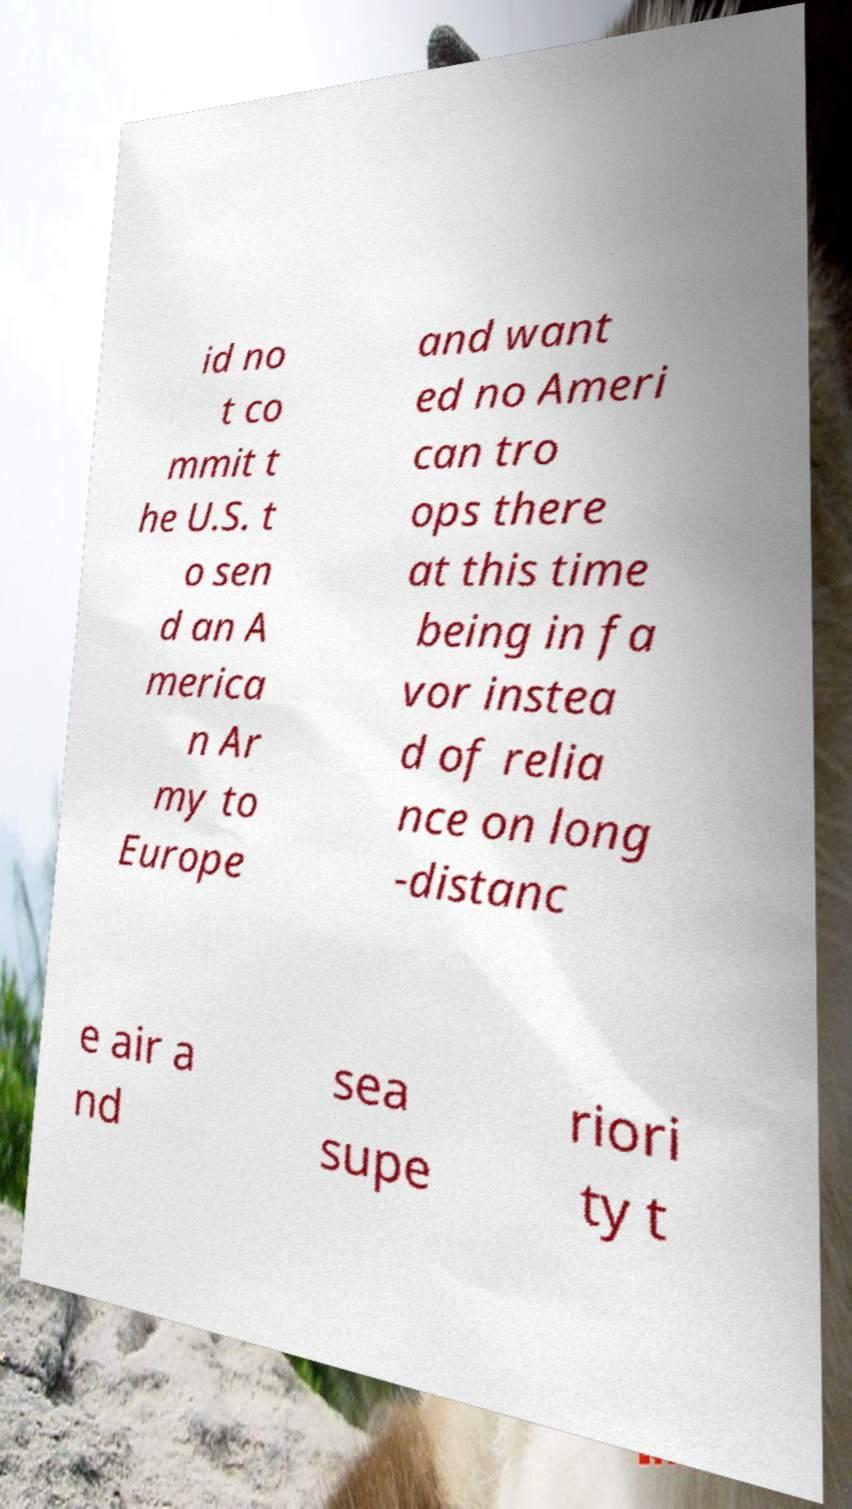Please identify and transcribe the text found in this image. id no t co mmit t he U.S. t o sen d an A merica n Ar my to Europe and want ed no Ameri can tro ops there at this time being in fa vor instea d of relia nce on long -distanc e air a nd sea supe riori ty t 